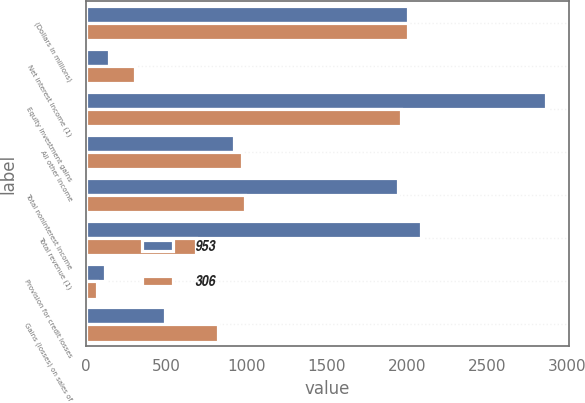Convert chart. <chart><loc_0><loc_0><loc_500><loc_500><stacked_bar_chart><ecel><fcel>(Dollars in millions)<fcel>Net interest income (1)<fcel>Equity investment gains<fcel>All other income<fcel>Total noninterest income<fcel>Total revenue (1)<fcel>Provision for credit losses<fcel>Gains (losses) on sales of<nl><fcel>953<fcel>2006<fcel>141<fcel>2866<fcel>921<fcel>1945<fcel>2086<fcel>116<fcel>495<nl><fcel>306<fcel>2005<fcel>305<fcel>1964<fcel>975<fcel>989<fcel>684<fcel>69<fcel>823<nl></chart> 